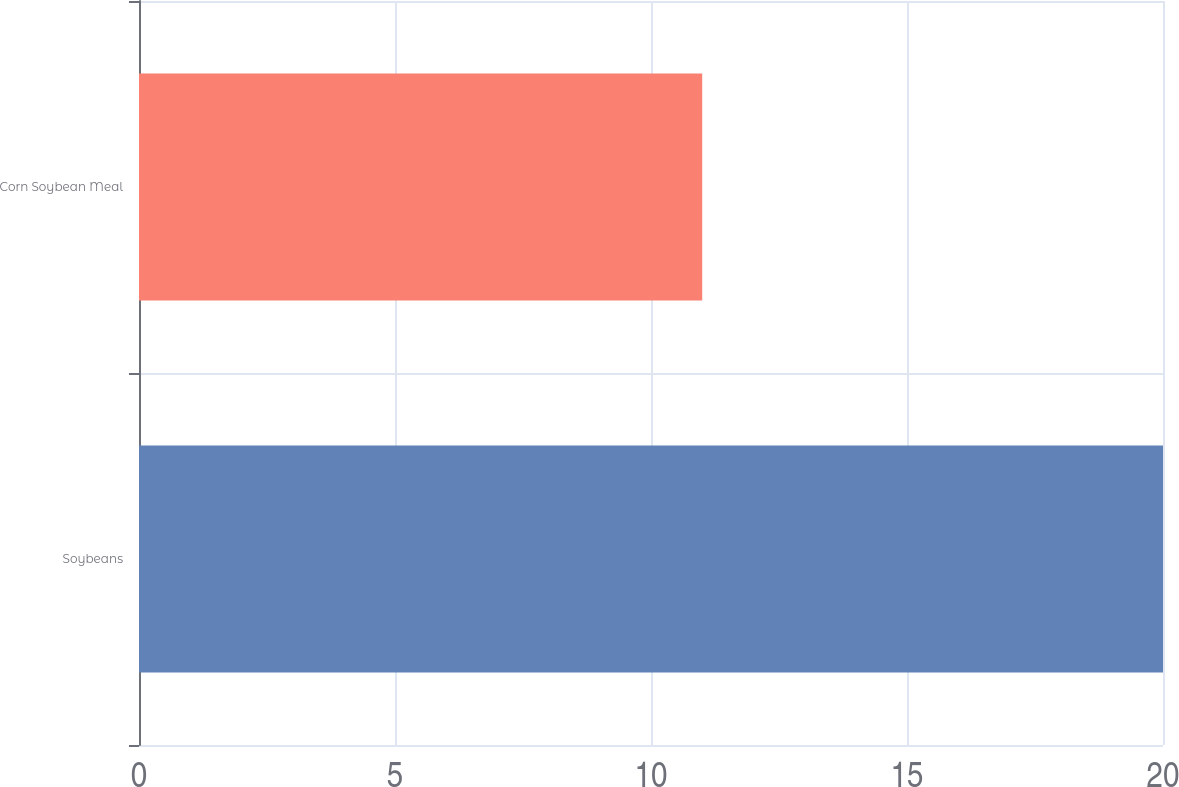<chart> <loc_0><loc_0><loc_500><loc_500><bar_chart><fcel>Soybeans<fcel>Corn Soybean Meal<nl><fcel>20<fcel>11<nl></chart> 